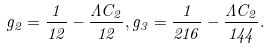Convert formula to latex. <formula><loc_0><loc_0><loc_500><loc_500>g _ { 2 } = \frac { 1 } { 1 2 } - \frac { \Lambda C _ { 2 } } { 1 2 } , g _ { 3 } = \frac { 1 } { 2 1 6 } - \frac { \Lambda C _ { 2 } } { 1 4 4 } .</formula> 